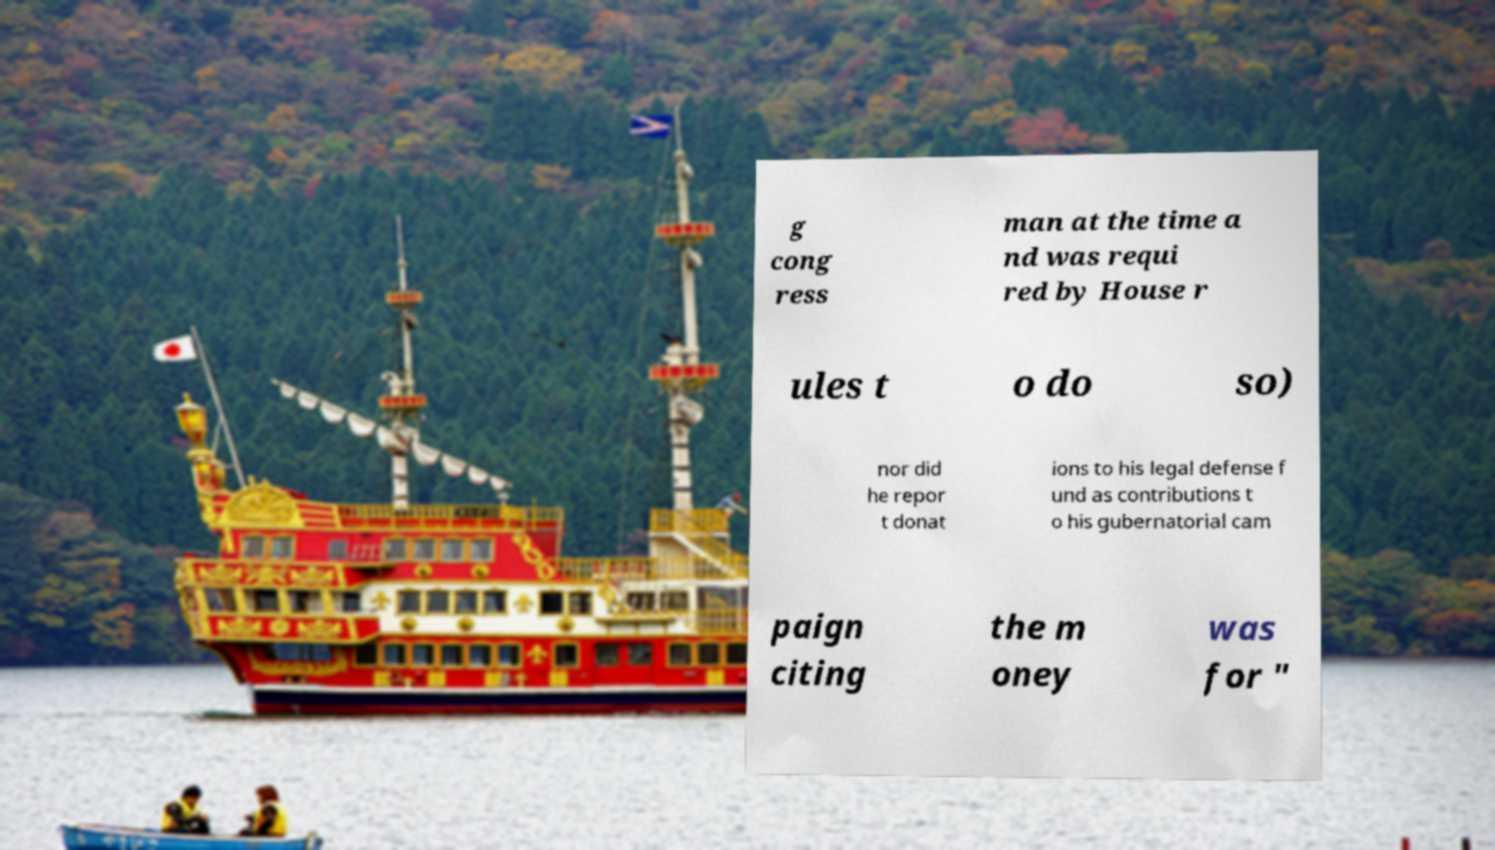Could you assist in decoding the text presented in this image and type it out clearly? g cong ress man at the time a nd was requi red by House r ules t o do so) nor did he repor t donat ions to his legal defense f und as contributions t o his gubernatorial cam paign citing the m oney was for " 